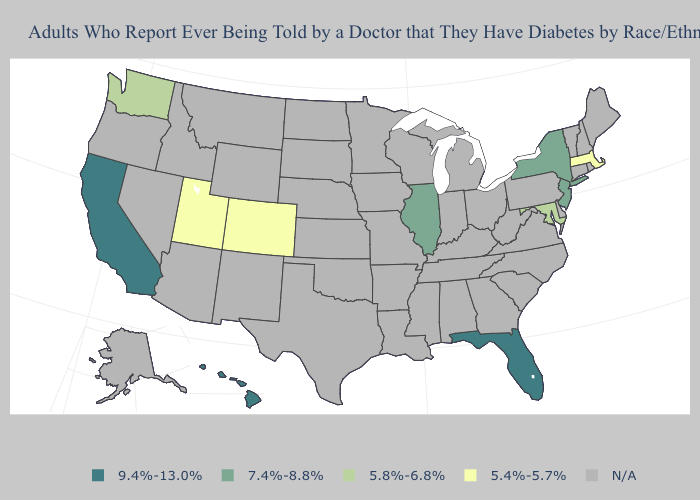What is the value of North Carolina?
Answer briefly. N/A. Does New York have the highest value in the Northeast?
Answer briefly. Yes. Name the states that have a value in the range N/A?
Quick response, please. Alabama, Alaska, Arizona, Arkansas, Connecticut, Delaware, Georgia, Idaho, Indiana, Iowa, Kansas, Kentucky, Louisiana, Maine, Michigan, Minnesota, Mississippi, Missouri, Montana, Nebraska, Nevada, New Hampshire, New Mexico, North Carolina, North Dakota, Ohio, Oklahoma, Oregon, Pennsylvania, Rhode Island, South Carolina, South Dakota, Tennessee, Texas, Vermont, Virginia, West Virginia, Wisconsin, Wyoming. What is the value of Arkansas?
Keep it brief. N/A. Name the states that have a value in the range 7.4%-8.8%?
Keep it brief. Illinois, New Jersey, New York. What is the highest value in the USA?
Be succinct. 9.4%-13.0%. Name the states that have a value in the range 5.4%-5.7%?
Concise answer only. Colorado, Massachusetts, Utah. Which states have the lowest value in the West?
Concise answer only. Colorado, Utah. Name the states that have a value in the range N/A?
Answer briefly. Alabama, Alaska, Arizona, Arkansas, Connecticut, Delaware, Georgia, Idaho, Indiana, Iowa, Kansas, Kentucky, Louisiana, Maine, Michigan, Minnesota, Mississippi, Missouri, Montana, Nebraska, Nevada, New Hampshire, New Mexico, North Carolina, North Dakota, Ohio, Oklahoma, Oregon, Pennsylvania, Rhode Island, South Carolina, South Dakota, Tennessee, Texas, Vermont, Virginia, West Virginia, Wisconsin, Wyoming. Name the states that have a value in the range 5.4%-5.7%?
Quick response, please. Colorado, Massachusetts, Utah. What is the value of New Jersey?
Write a very short answer. 7.4%-8.8%. Does Massachusetts have the lowest value in the USA?
Give a very brief answer. Yes. Which states have the lowest value in the USA?
Write a very short answer. Colorado, Massachusetts, Utah. Name the states that have a value in the range 5.8%-6.8%?
Give a very brief answer. Maryland, Washington. Among the states that border Wisconsin , which have the highest value?
Write a very short answer. Illinois. 